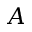Convert formula to latex. <formula><loc_0><loc_0><loc_500><loc_500>A</formula> 